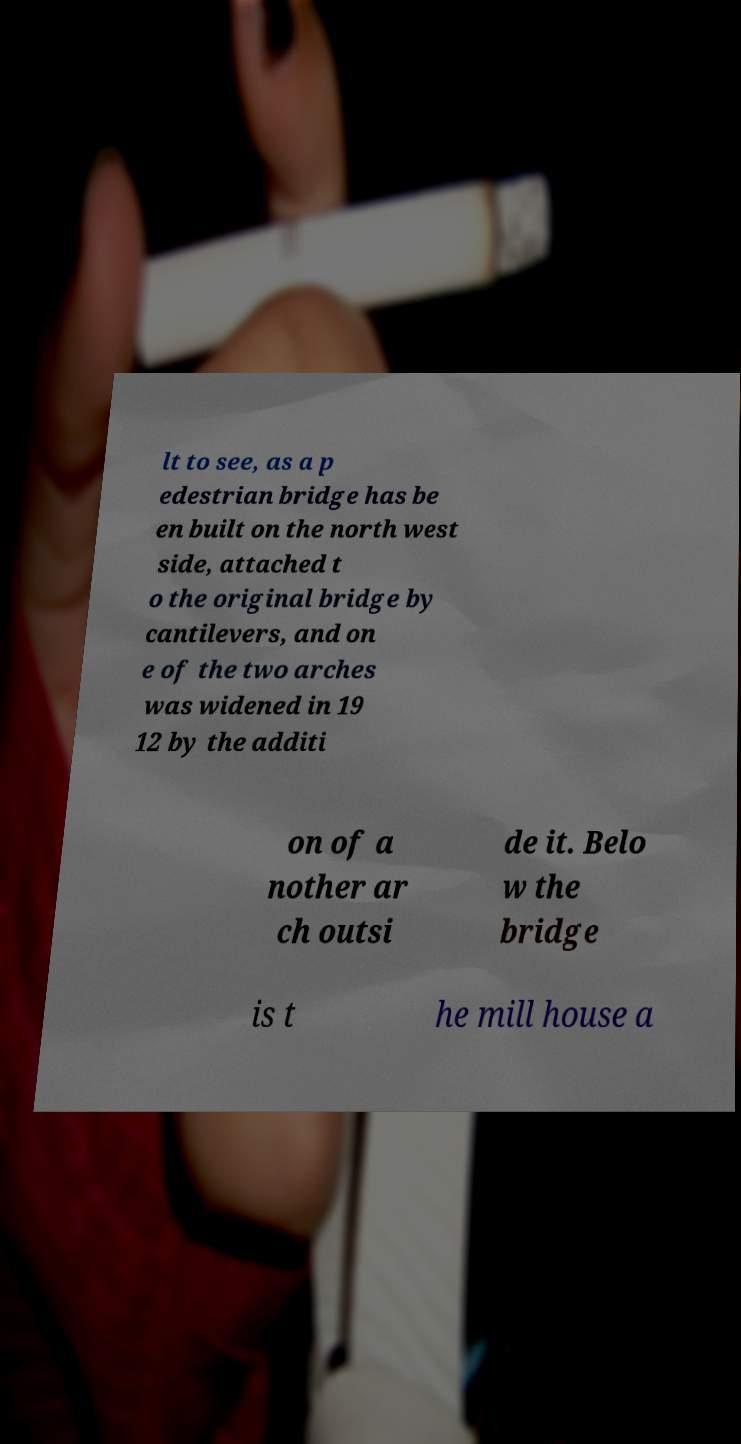Please identify and transcribe the text found in this image. lt to see, as a p edestrian bridge has be en built on the north west side, attached t o the original bridge by cantilevers, and on e of the two arches was widened in 19 12 by the additi on of a nother ar ch outsi de it. Belo w the bridge is t he mill house a 